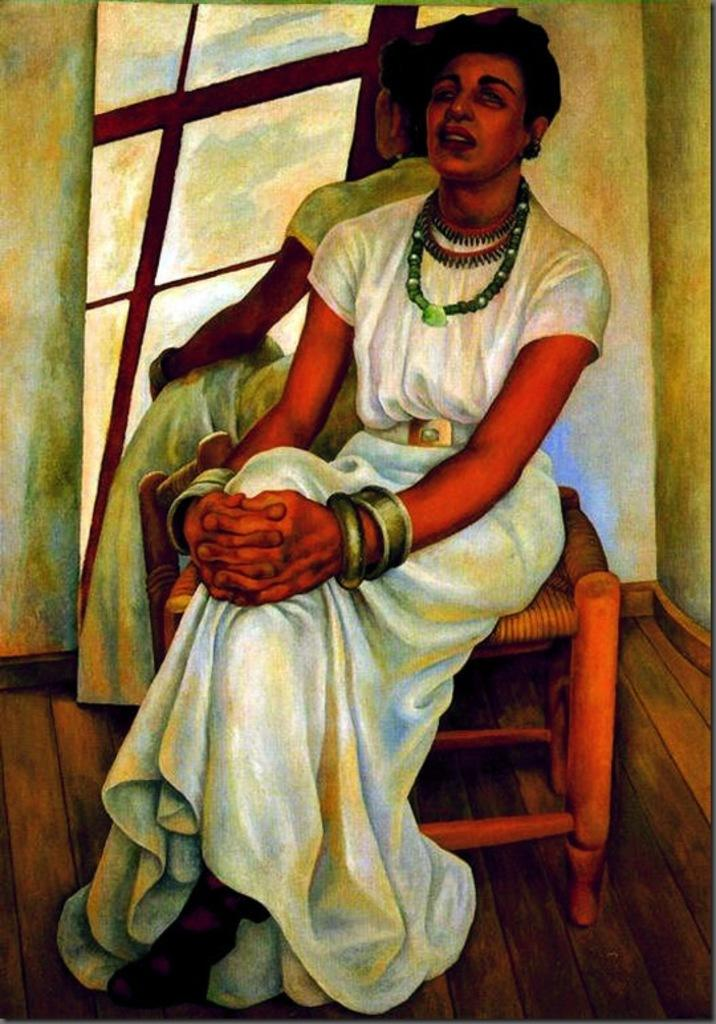What is the main subject of the painting? The painting depicts a lady. What is the lady wearing in the painting? The lady is wearing a white dress in the painting. What is the lady's position in the painting? The lady is sitting on a table in the painting. What other object can be seen in the painting? There is a mirror in the painting. Can you tell me how many jars are visible in the painting? There are no jars present in the painting; it features a lady, a white dress, a table, and a mirror. What type of camera is being used to capture the painting? The painting is a static image and does not require a camera to be captured. 